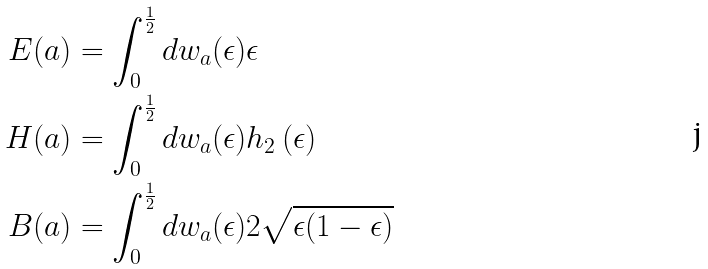<formula> <loc_0><loc_0><loc_500><loc_500>E ( a ) & = \int _ { 0 } ^ { \frac { 1 } { 2 } } d w _ { a } ( \epsilon ) \epsilon \\ H ( a ) & = \int _ { 0 } ^ { \frac { 1 } { 2 } } d w _ { a } ( \epsilon ) h _ { 2 } \left ( \epsilon \right ) \\ B ( a ) & = \int _ { 0 } ^ { \frac { 1 } { 2 } } d w _ { a } ( \epsilon ) 2 \sqrt { \epsilon ( 1 - \epsilon ) }</formula> 